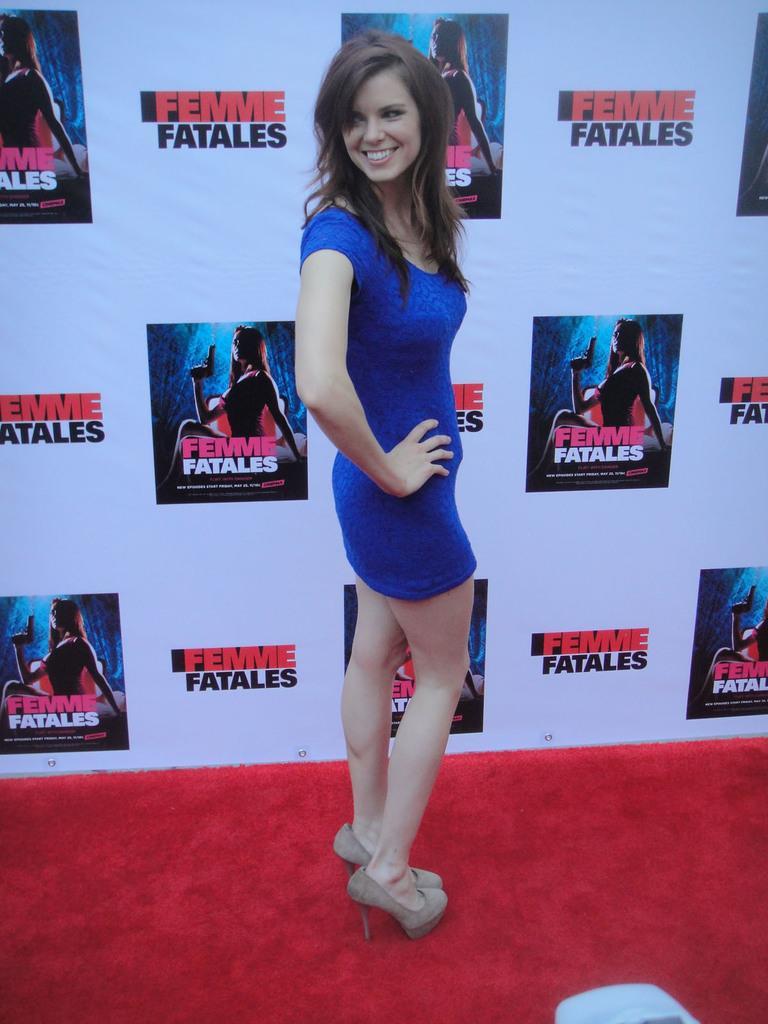In one or two sentences, can you explain what this image depicts? In this picture there is a girl who is standing in the center of the image and there is a red color rug at the bottom side of the image and there is a poster in the background area of the image. 